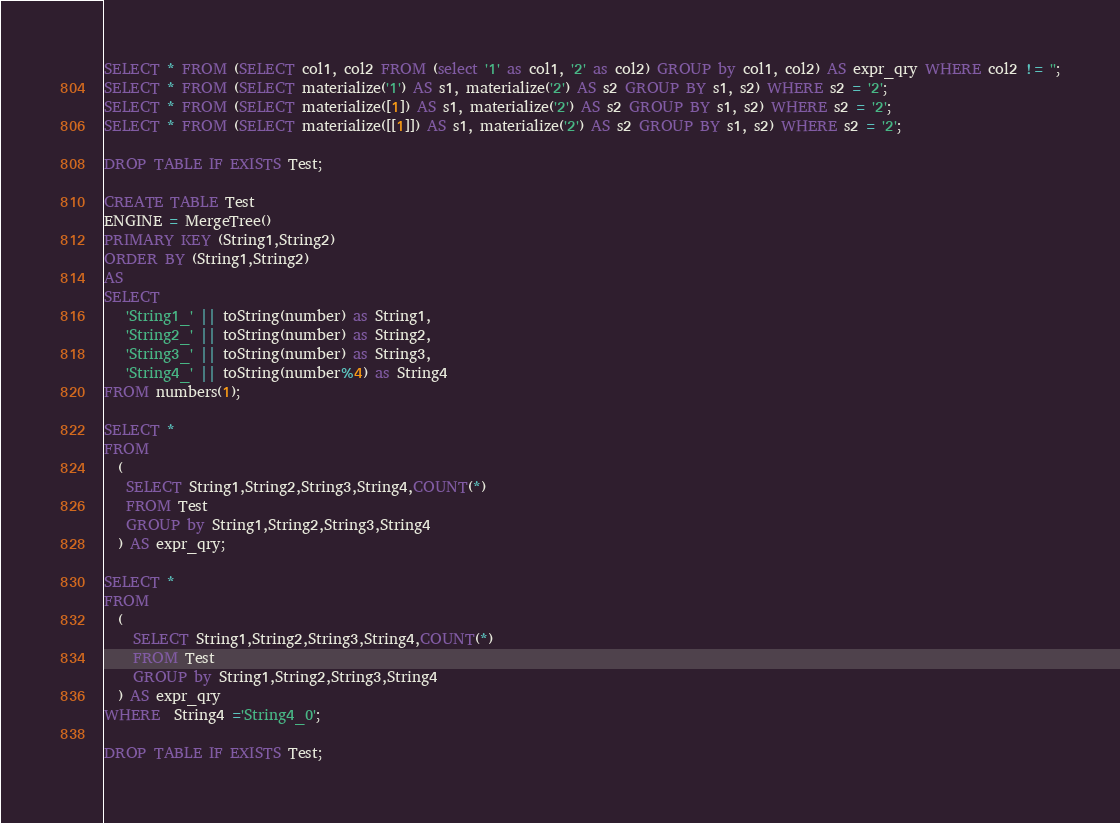<code> <loc_0><loc_0><loc_500><loc_500><_SQL_>SELECT * FROM (SELECT col1, col2 FROM (select '1' as col1, '2' as col2) GROUP by col1, col2) AS expr_qry WHERE col2 != '';
SELECT * FROM (SELECT materialize('1') AS s1, materialize('2') AS s2 GROUP BY s1, s2) WHERE s2 = '2';
SELECT * FROM (SELECT materialize([1]) AS s1, materialize('2') AS s2 GROUP BY s1, s2) WHERE s2 = '2';
SELECT * FROM (SELECT materialize([[1]]) AS s1, materialize('2') AS s2 GROUP BY s1, s2) WHERE s2 = '2';

DROP TABLE IF EXISTS Test;

CREATE TABLE Test
ENGINE = MergeTree()
PRIMARY KEY (String1,String2)
ORDER BY (String1,String2)
AS 
SELECT
   'String1_' || toString(number) as String1,
   'String2_' || toString(number) as String2,
   'String3_' || toString(number) as String3,
   'String4_' || toString(number%4) as String4
FROM numbers(1);

SELECT *
FROM
  (
   SELECT String1,String2,String3,String4,COUNT(*)
   FROM Test
   GROUP by String1,String2,String3,String4
  ) AS expr_qry;

SELECT *
FROM
  (
    SELECT String1,String2,String3,String4,COUNT(*)
    FROM Test
    GROUP by String1,String2,String3,String4
  ) AS expr_qry
WHERE  String4 ='String4_0';

DROP TABLE IF EXISTS Test;
</code> 